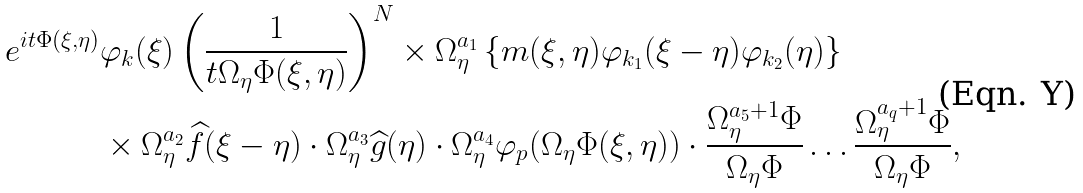Convert formula to latex. <formula><loc_0><loc_0><loc_500><loc_500>e ^ { i t \Phi ( \xi , \eta ) } & \varphi _ { k } ( \xi ) \left ( \frac { 1 } { t \Omega _ { \eta } \Phi ( \xi , \eta ) } \right ) ^ { N } \times \Omega ^ { a _ { 1 } } _ { \eta } \left \{ m ( \xi , \eta ) \varphi _ { k _ { 1 } } ( \xi - \eta ) \varphi _ { k _ { 2 } } ( \eta ) \right \} \\ & \times \Omega _ { \eta } ^ { a _ { 2 } } \widehat { f } ( \xi - \eta ) \cdot \Omega _ { \eta } ^ { a _ { 3 } } \widehat { g } ( \eta ) \cdot \Omega _ { \eta } ^ { a _ { 4 } } \varphi _ { p } ( \Omega _ { \eta } \Phi ( \xi , \eta ) ) \cdot \frac { \Omega ^ { a _ { 5 } + 1 } _ { \eta } \Phi } { \Omega _ { \eta } \Phi } \dots \frac { \Omega _ { \eta } ^ { a _ { q } + 1 } \Phi } { \Omega _ { \eta } \Phi } ,</formula> 